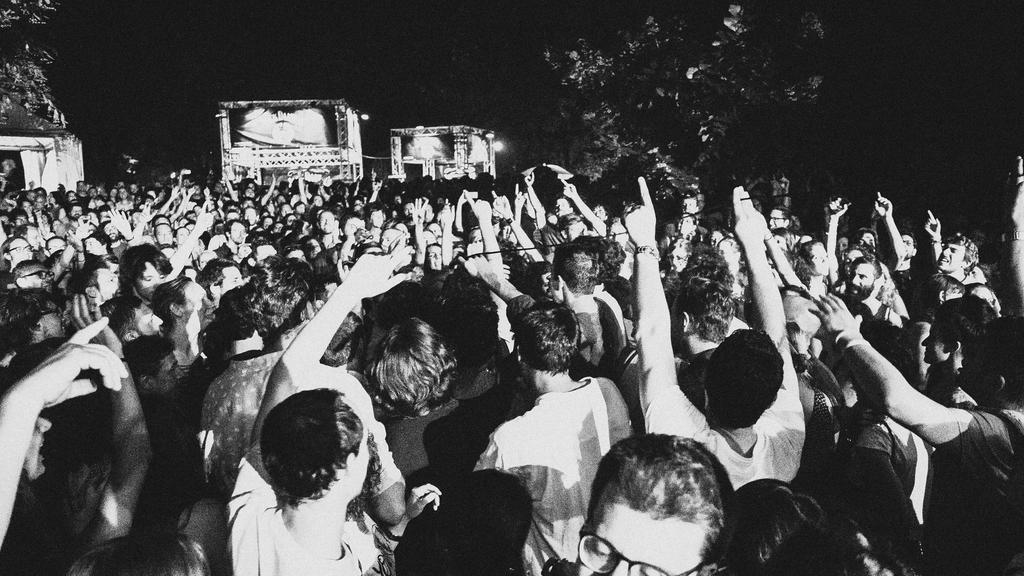How would you summarize this image in a sentence or two? This is a black and white image, in this image there are group of people who are standing. And in the background there are trees and objects, and also we could see some lights. 